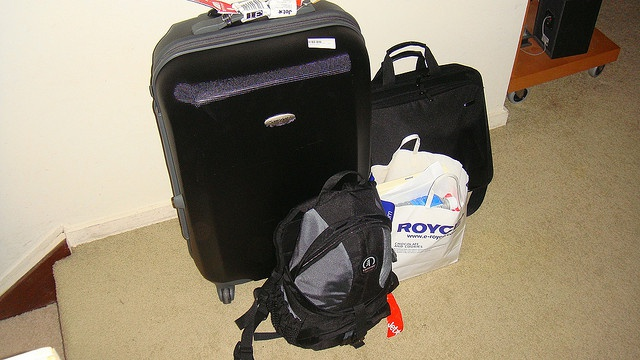Describe the objects in this image and their specific colors. I can see suitcase in beige, black, gray, and ivory tones, backpack in beige, black, and gray tones, and handbag in beige, black, and gray tones in this image. 